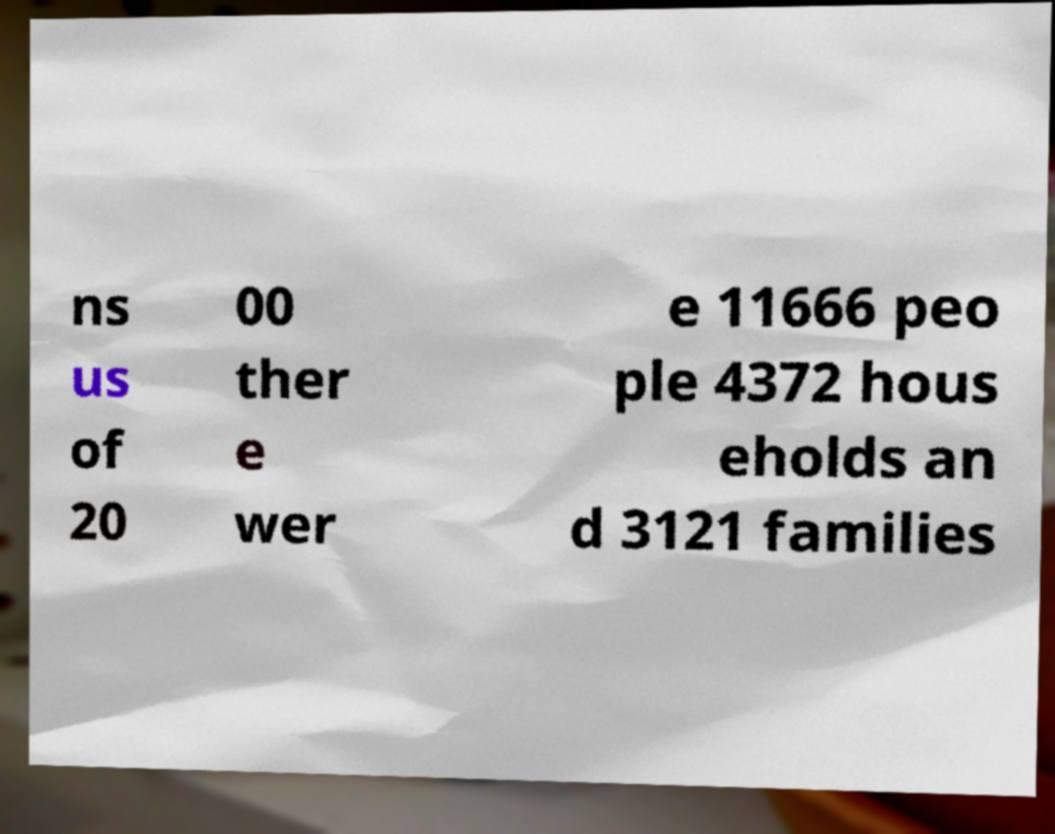Could you assist in decoding the text presented in this image and type it out clearly? ns us of 20 00 ther e wer e 11666 peo ple 4372 hous eholds an d 3121 families 